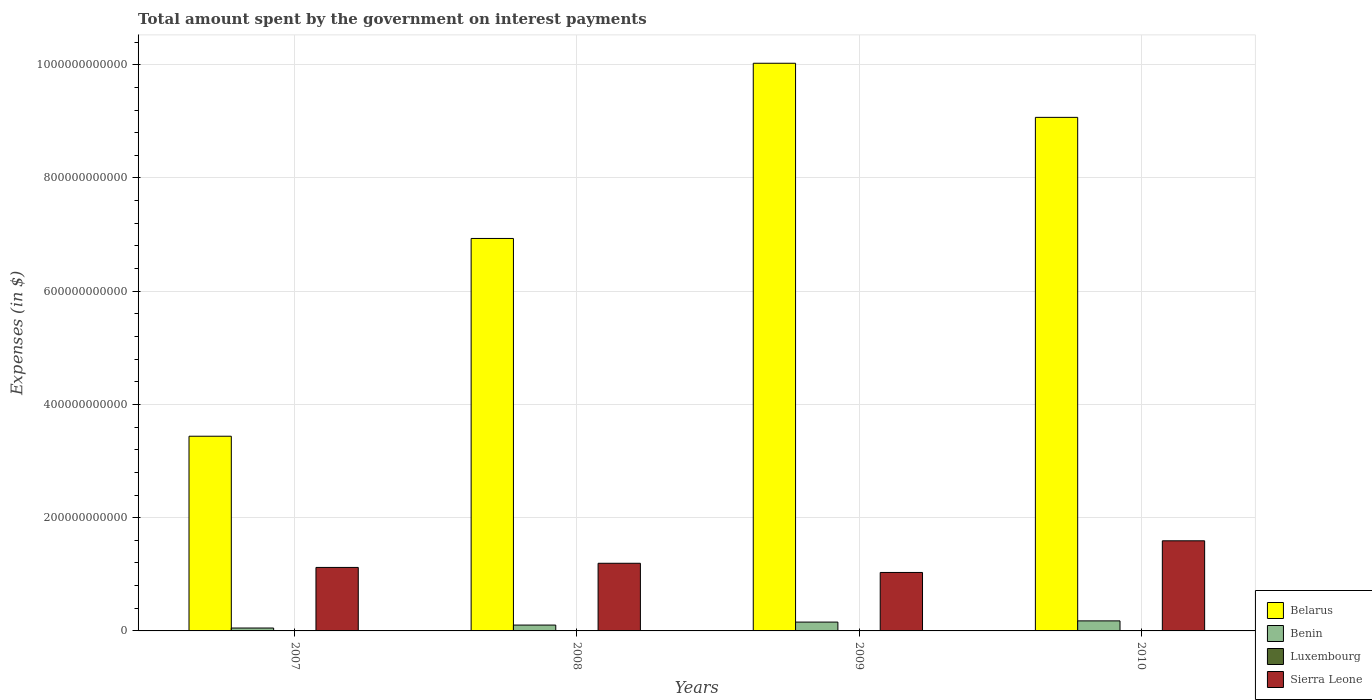How many groups of bars are there?
Your answer should be compact. 4. Are the number of bars per tick equal to the number of legend labels?
Keep it short and to the point. Yes. How many bars are there on the 2nd tick from the right?
Your answer should be very brief. 4. In how many cases, is the number of bars for a given year not equal to the number of legend labels?
Offer a terse response. 0. What is the amount spent on interest payments by the government in Sierra Leone in 2008?
Make the answer very short. 1.19e+11. Across all years, what is the maximum amount spent on interest payments by the government in Benin?
Give a very brief answer. 1.77e+1. Across all years, what is the minimum amount spent on interest payments by the government in Benin?
Keep it short and to the point. 5.13e+09. What is the total amount spent on interest payments by the government in Belarus in the graph?
Provide a short and direct response. 2.95e+12. What is the difference between the amount spent on interest payments by the government in Sierra Leone in 2008 and that in 2010?
Make the answer very short. -3.97e+1. What is the difference between the amount spent on interest payments by the government in Benin in 2008 and the amount spent on interest payments by the government in Sierra Leone in 2009?
Offer a terse response. -9.29e+1. What is the average amount spent on interest payments by the government in Benin per year?
Provide a succinct answer. 1.22e+1. In the year 2007, what is the difference between the amount spent on interest payments by the government in Benin and amount spent on interest payments by the government in Luxembourg?
Offer a very short reply. 5.07e+09. In how many years, is the amount spent on interest payments by the government in Sierra Leone greater than 40000000000 $?
Offer a very short reply. 4. What is the ratio of the amount spent on interest payments by the government in Benin in 2008 to that in 2009?
Give a very brief answer. 0.66. Is the amount spent on interest payments by the government in Benin in 2007 less than that in 2010?
Provide a short and direct response. Yes. Is the difference between the amount spent on interest payments by the government in Benin in 2007 and 2010 greater than the difference between the amount spent on interest payments by the government in Luxembourg in 2007 and 2010?
Provide a short and direct response. No. What is the difference between the highest and the second highest amount spent on interest payments by the government in Benin?
Give a very brief answer. 2.14e+09. What is the difference between the highest and the lowest amount spent on interest payments by the government in Luxembourg?
Keep it short and to the point. 9.34e+07. In how many years, is the amount spent on interest payments by the government in Luxembourg greater than the average amount spent on interest payments by the government in Luxembourg taken over all years?
Offer a terse response. 2. Is the sum of the amount spent on interest payments by the government in Luxembourg in 2008 and 2009 greater than the maximum amount spent on interest payments by the government in Benin across all years?
Your answer should be compact. No. Is it the case that in every year, the sum of the amount spent on interest payments by the government in Belarus and amount spent on interest payments by the government in Luxembourg is greater than the sum of amount spent on interest payments by the government in Sierra Leone and amount spent on interest payments by the government in Benin?
Provide a short and direct response. Yes. What does the 1st bar from the left in 2010 represents?
Your response must be concise. Belarus. What does the 2nd bar from the right in 2007 represents?
Give a very brief answer. Luxembourg. How many bars are there?
Make the answer very short. 16. What is the difference between two consecutive major ticks on the Y-axis?
Provide a succinct answer. 2.00e+11. Does the graph contain any zero values?
Ensure brevity in your answer.  No. Where does the legend appear in the graph?
Ensure brevity in your answer.  Bottom right. How are the legend labels stacked?
Offer a very short reply. Vertical. What is the title of the graph?
Give a very brief answer. Total amount spent by the government on interest payments. Does "Korea (Democratic)" appear as one of the legend labels in the graph?
Give a very brief answer. No. What is the label or title of the Y-axis?
Your response must be concise. Expenses (in $). What is the Expenses (in $) of Belarus in 2007?
Provide a short and direct response. 3.44e+11. What is the Expenses (in $) of Benin in 2007?
Make the answer very short. 5.13e+09. What is the Expenses (in $) in Luxembourg in 2007?
Your answer should be compact. 5.74e+07. What is the Expenses (in $) of Sierra Leone in 2007?
Make the answer very short. 1.12e+11. What is the Expenses (in $) in Belarus in 2008?
Your answer should be very brief. 6.93e+11. What is the Expenses (in $) of Benin in 2008?
Your answer should be compact. 1.03e+1. What is the Expenses (in $) of Luxembourg in 2008?
Offer a very short reply. 8.89e+07. What is the Expenses (in $) in Sierra Leone in 2008?
Provide a succinct answer. 1.19e+11. What is the Expenses (in $) in Belarus in 2009?
Your response must be concise. 1.00e+12. What is the Expenses (in $) in Benin in 2009?
Offer a very short reply. 1.56e+1. What is the Expenses (in $) of Luxembourg in 2009?
Give a very brief answer. 1.20e+08. What is the Expenses (in $) of Sierra Leone in 2009?
Offer a terse response. 1.03e+11. What is the Expenses (in $) in Belarus in 2010?
Make the answer very short. 9.07e+11. What is the Expenses (in $) of Benin in 2010?
Your answer should be very brief. 1.77e+1. What is the Expenses (in $) of Luxembourg in 2010?
Make the answer very short. 1.51e+08. What is the Expenses (in $) of Sierra Leone in 2010?
Make the answer very short. 1.59e+11. Across all years, what is the maximum Expenses (in $) in Belarus?
Your answer should be very brief. 1.00e+12. Across all years, what is the maximum Expenses (in $) of Benin?
Offer a very short reply. 1.77e+1. Across all years, what is the maximum Expenses (in $) of Luxembourg?
Offer a terse response. 1.51e+08. Across all years, what is the maximum Expenses (in $) of Sierra Leone?
Your answer should be very brief. 1.59e+11. Across all years, what is the minimum Expenses (in $) in Belarus?
Ensure brevity in your answer.  3.44e+11. Across all years, what is the minimum Expenses (in $) in Benin?
Your answer should be compact. 5.13e+09. Across all years, what is the minimum Expenses (in $) of Luxembourg?
Keep it short and to the point. 5.74e+07. Across all years, what is the minimum Expenses (in $) in Sierra Leone?
Your answer should be very brief. 1.03e+11. What is the total Expenses (in $) of Belarus in the graph?
Your answer should be very brief. 2.95e+12. What is the total Expenses (in $) in Benin in the graph?
Provide a succinct answer. 4.88e+1. What is the total Expenses (in $) of Luxembourg in the graph?
Give a very brief answer. 4.17e+08. What is the total Expenses (in $) of Sierra Leone in the graph?
Offer a terse response. 4.94e+11. What is the difference between the Expenses (in $) of Belarus in 2007 and that in 2008?
Provide a succinct answer. -3.49e+11. What is the difference between the Expenses (in $) of Benin in 2007 and that in 2008?
Make the answer very short. -5.22e+09. What is the difference between the Expenses (in $) in Luxembourg in 2007 and that in 2008?
Keep it short and to the point. -3.15e+07. What is the difference between the Expenses (in $) in Sierra Leone in 2007 and that in 2008?
Offer a very short reply. -7.35e+09. What is the difference between the Expenses (in $) of Belarus in 2007 and that in 2009?
Ensure brevity in your answer.  -6.59e+11. What is the difference between the Expenses (in $) in Benin in 2007 and that in 2009?
Make the answer very short. -1.05e+1. What is the difference between the Expenses (in $) of Luxembourg in 2007 and that in 2009?
Ensure brevity in your answer.  -6.29e+07. What is the difference between the Expenses (in $) of Sierra Leone in 2007 and that in 2009?
Your answer should be compact. 8.90e+09. What is the difference between the Expenses (in $) of Belarus in 2007 and that in 2010?
Give a very brief answer. -5.63e+11. What is the difference between the Expenses (in $) in Benin in 2007 and that in 2010?
Your answer should be compact. -1.26e+1. What is the difference between the Expenses (in $) of Luxembourg in 2007 and that in 2010?
Keep it short and to the point. -9.34e+07. What is the difference between the Expenses (in $) in Sierra Leone in 2007 and that in 2010?
Offer a very short reply. -4.70e+1. What is the difference between the Expenses (in $) of Belarus in 2008 and that in 2009?
Your answer should be very brief. -3.09e+11. What is the difference between the Expenses (in $) of Benin in 2008 and that in 2009?
Make the answer very short. -5.25e+09. What is the difference between the Expenses (in $) in Luxembourg in 2008 and that in 2009?
Keep it short and to the point. -3.14e+07. What is the difference between the Expenses (in $) in Sierra Leone in 2008 and that in 2009?
Your answer should be very brief. 1.62e+1. What is the difference between the Expenses (in $) in Belarus in 2008 and that in 2010?
Provide a short and direct response. -2.14e+11. What is the difference between the Expenses (in $) of Benin in 2008 and that in 2010?
Give a very brief answer. -7.39e+09. What is the difference between the Expenses (in $) in Luxembourg in 2008 and that in 2010?
Your answer should be compact. -6.20e+07. What is the difference between the Expenses (in $) in Sierra Leone in 2008 and that in 2010?
Offer a very short reply. -3.97e+1. What is the difference between the Expenses (in $) of Belarus in 2009 and that in 2010?
Your answer should be very brief. 9.56e+1. What is the difference between the Expenses (in $) of Benin in 2009 and that in 2010?
Keep it short and to the point. -2.14e+09. What is the difference between the Expenses (in $) of Luxembourg in 2009 and that in 2010?
Your answer should be compact. -3.06e+07. What is the difference between the Expenses (in $) of Sierra Leone in 2009 and that in 2010?
Offer a very short reply. -5.59e+1. What is the difference between the Expenses (in $) in Belarus in 2007 and the Expenses (in $) in Benin in 2008?
Provide a succinct answer. 3.34e+11. What is the difference between the Expenses (in $) of Belarus in 2007 and the Expenses (in $) of Luxembourg in 2008?
Ensure brevity in your answer.  3.44e+11. What is the difference between the Expenses (in $) in Belarus in 2007 and the Expenses (in $) in Sierra Leone in 2008?
Your response must be concise. 2.24e+11. What is the difference between the Expenses (in $) in Benin in 2007 and the Expenses (in $) in Luxembourg in 2008?
Give a very brief answer. 5.04e+09. What is the difference between the Expenses (in $) in Benin in 2007 and the Expenses (in $) in Sierra Leone in 2008?
Ensure brevity in your answer.  -1.14e+11. What is the difference between the Expenses (in $) in Luxembourg in 2007 and the Expenses (in $) in Sierra Leone in 2008?
Your answer should be very brief. -1.19e+11. What is the difference between the Expenses (in $) of Belarus in 2007 and the Expenses (in $) of Benin in 2009?
Provide a succinct answer. 3.28e+11. What is the difference between the Expenses (in $) of Belarus in 2007 and the Expenses (in $) of Luxembourg in 2009?
Offer a very short reply. 3.44e+11. What is the difference between the Expenses (in $) of Belarus in 2007 and the Expenses (in $) of Sierra Leone in 2009?
Provide a short and direct response. 2.41e+11. What is the difference between the Expenses (in $) of Benin in 2007 and the Expenses (in $) of Luxembourg in 2009?
Keep it short and to the point. 5.01e+09. What is the difference between the Expenses (in $) in Benin in 2007 and the Expenses (in $) in Sierra Leone in 2009?
Offer a very short reply. -9.81e+1. What is the difference between the Expenses (in $) in Luxembourg in 2007 and the Expenses (in $) in Sierra Leone in 2009?
Provide a succinct answer. -1.03e+11. What is the difference between the Expenses (in $) in Belarus in 2007 and the Expenses (in $) in Benin in 2010?
Make the answer very short. 3.26e+11. What is the difference between the Expenses (in $) in Belarus in 2007 and the Expenses (in $) in Luxembourg in 2010?
Your answer should be compact. 3.44e+11. What is the difference between the Expenses (in $) of Belarus in 2007 and the Expenses (in $) of Sierra Leone in 2010?
Make the answer very short. 1.85e+11. What is the difference between the Expenses (in $) in Benin in 2007 and the Expenses (in $) in Luxembourg in 2010?
Your response must be concise. 4.98e+09. What is the difference between the Expenses (in $) of Benin in 2007 and the Expenses (in $) of Sierra Leone in 2010?
Provide a succinct answer. -1.54e+11. What is the difference between the Expenses (in $) in Luxembourg in 2007 and the Expenses (in $) in Sierra Leone in 2010?
Ensure brevity in your answer.  -1.59e+11. What is the difference between the Expenses (in $) of Belarus in 2008 and the Expenses (in $) of Benin in 2009?
Provide a short and direct response. 6.78e+11. What is the difference between the Expenses (in $) of Belarus in 2008 and the Expenses (in $) of Luxembourg in 2009?
Provide a succinct answer. 6.93e+11. What is the difference between the Expenses (in $) of Belarus in 2008 and the Expenses (in $) of Sierra Leone in 2009?
Give a very brief answer. 5.90e+11. What is the difference between the Expenses (in $) of Benin in 2008 and the Expenses (in $) of Luxembourg in 2009?
Your response must be concise. 1.02e+1. What is the difference between the Expenses (in $) in Benin in 2008 and the Expenses (in $) in Sierra Leone in 2009?
Make the answer very short. -9.29e+1. What is the difference between the Expenses (in $) of Luxembourg in 2008 and the Expenses (in $) of Sierra Leone in 2009?
Make the answer very short. -1.03e+11. What is the difference between the Expenses (in $) of Belarus in 2008 and the Expenses (in $) of Benin in 2010?
Offer a terse response. 6.75e+11. What is the difference between the Expenses (in $) in Belarus in 2008 and the Expenses (in $) in Luxembourg in 2010?
Ensure brevity in your answer.  6.93e+11. What is the difference between the Expenses (in $) in Belarus in 2008 and the Expenses (in $) in Sierra Leone in 2010?
Ensure brevity in your answer.  5.34e+11. What is the difference between the Expenses (in $) in Benin in 2008 and the Expenses (in $) in Luxembourg in 2010?
Ensure brevity in your answer.  1.02e+1. What is the difference between the Expenses (in $) of Benin in 2008 and the Expenses (in $) of Sierra Leone in 2010?
Your answer should be very brief. -1.49e+11. What is the difference between the Expenses (in $) of Luxembourg in 2008 and the Expenses (in $) of Sierra Leone in 2010?
Give a very brief answer. -1.59e+11. What is the difference between the Expenses (in $) of Belarus in 2009 and the Expenses (in $) of Benin in 2010?
Make the answer very short. 9.85e+11. What is the difference between the Expenses (in $) in Belarus in 2009 and the Expenses (in $) in Luxembourg in 2010?
Make the answer very short. 1.00e+12. What is the difference between the Expenses (in $) in Belarus in 2009 and the Expenses (in $) in Sierra Leone in 2010?
Keep it short and to the point. 8.43e+11. What is the difference between the Expenses (in $) of Benin in 2009 and the Expenses (in $) of Luxembourg in 2010?
Make the answer very short. 1.54e+1. What is the difference between the Expenses (in $) of Benin in 2009 and the Expenses (in $) of Sierra Leone in 2010?
Provide a succinct answer. -1.44e+11. What is the difference between the Expenses (in $) of Luxembourg in 2009 and the Expenses (in $) of Sierra Leone in 2010?
Offer a very short reply. -1.59e+11. What is the average Expenses (in $) of Belarus per year?
Offer a very short reply. 7.37e+11. What is the average Expenses (in $) of Benin per year?
Provide a short and direct response. 1.22e+1. What is the average Expenses (in $) in Luxembourg per year?
Give a very brief answer. 1.04e+08. What is the average Expenses (in $) of Sierra Leone per year?
Your response must be concise. 1.24e+11. In the year 2007, what is the difference between the Expenses (in $) of Belarus and Expenses (in $) of Benin?
Provide a succinct answer. 3.39e+11. In the year 2007, what is the difference between the Expenses (in $) in Belarus and Expenses (in $) in Luxembourg?
Give a very brief answer. 3.44e+11. In the year 2007, what is the difference between the Expenses (in $) of Belarus and Expenses (in $) of Sierra Leone?
Provide a short and direct response. 2.32e+11. In the year 2007, what is the difference between the Expenses (in $) in Benin and Expenses (in $) in Luxembourg?
Give a very brief answer. 5.07e+09. In the year 2007, what is the difference between the Expenses (in $) in Benin and Expenses (in $) in Sierra Leone?
Offer a terse response. -1.07e+11. In the year 2007, what is the difference between the Expenses (in $) of Luxembourg and Expenses (in $) of Sierra Leone?
Ensure brevity in your answer.  -1.12e+11. In the year 2008, what is the difference between the Expenses (in $) in Belarus and Expenses (in $) in Benin?
Your answer should be very brief. 6.83e+11. In the year 2008, what is the difference between the Expenses (in $) of Belarus and Expenses (in $) of Luxembourg?
Give a very brief answer. 6.93e+11. In the year 2008, what is the difference between the Expenses (in $) of Belarus and Expenses (in $) of Sierra Leone?
Make the answer very short. 5.74e+11. In the year 2008, what is the difference between the Expenses (in $) in Benin and Expenses (in $) in Luxembourg?
Your answer should be compact. 1.03e+1. In the year 2008, what is the difference between the Expenses (in $) of Benin and Expenses (in $) of Sierra Leone?
Make the answer very short. -1.09e+11. In the year 2008, what is the difference between the Expenses (in $) of Luxembourg and Expenses (in $) of Sierra Leone?
Offer a terse response. -1.19e+11. In the year 2009, what is the difference between the Expenses (in $) of Belarus and Expenses (in $) of Benin?
Keep it short and to the point. 9.87e+11. In the year 2009, what is the difference between the Expenses (in $) of Belarus and Expenses (in $) of Luxembourg?
Your answer should be very brief. 1.00e+12. In the year 2009, what is the difference between the Expenses (in $) in Belarus and Expenses (in $) in Sierra Leone?
Your answer should be very brief. 8.99e+11. In the year 2009, what is the difference between the Expenses (in $) in Benin and Expenses (in $) in Luxembourg?
Your response must be concise. 1.55e+1. In the year 2009, what is the difference between the Expenses (in $) of Benin and Expenses (in $) of Sierra Leone?
Keep it short and to the point. -8.76e+1. In the year 2009, what is the difference between the Expenses (in $) of Luxembourg and Expenses (in $) of Sierra Leone?
Give a very brief answer. -1.03e+11. In the year 2010, what is the difference between the Expenses (in $) in Belarus and Expenses (in $) in Benin?
Offer a very short reply. 8.89e+11. In the year 2010, what is the difference between the Expenses (in $) of Belarus and Expenses (in $) of Luxembourg?
Provide a short and direct response. 9.07e+11. In the year 2010, what is the difference between the Expenses (in $) of Belarus and Expenses (in $) of Sierra Leone?
Provide a short and direct response. 7.48e+11. In the year 2010, what is the difference between the Expenses (in $) of Benin and Expenses (in $) of Luxembourg?
Provide a succinct answer. 1.76e+1. In the year 2010, what is the difference between the Expenses (in $) of Benin and Expenses (in $) of Sierra Leone?
Make the answer very short. -1.41e+11. In the year 2010, what is the difference between the Expenses (in $) of Luxembourg and Expenses (in $) of Sierra Leone?
Your answer should be compact. -1.59e+11. What is the ratio of the Expenses (in $) in Belarus in 2007 to that in 2008?
Provide a short and direct response. 0.5. What is the ratio of the Expenses (in $) in Benin in 2007 to that in 2008?
Your answer should be very brief. 0.5. What is the ratio of the Expenses (in $) of Luxembourg in 2007 to that in 2008?
Keep it short and to the point. 0.65. What is the ratio of the Expenses (in $) in Sierra Leone in 2007 to that in 2008?
Your answer should be very brief. 0.94. What is the ratio of the Expenses (in $) in Belarus in 2007 to that in 2009?
Give a very brief answer. 0.34. What is the ratio of the Expenses (in $) in Benin in 2007 to that in 2009?
Offer a terse response. 0.33. What is the ratio of the Expenses (in $) in Luxembourg in 2007 to that in 2009?
Ensure brevity in your answer.  0.48. What is the ratio of the Expenses (in $) of Sierra Leone in 2007 to that in 2009?
Your answer should be compact. 1.09. What is the ratio of the Expenses (in $) of Belarus in 2007 to that in 2010?
Provide a short and direct response. 0.38. What is the ratio of the Expenses (in $) of Benin in 2007 to that in 2010?
Provide a succinct answer. 0.29. What is the ratio of the Expenses (in $) of Luxembourg in 2007 to that in 2010?
Keep it short and to the point. 0.38. What is the ratio of the Expenses (in $) in Sierra Leone in 2007 to that in 2010?
Offer a terse response. 0.7. What is the ratio of the Expenses (in $) of Belarus in 2008 to that in 2009?
Provide a succinct answer. 0.69. What is the ratio of the Expenses (in $) of Benin in 2008 to that in 2009?
Make the answer very short. 0.66. What is the ratio of the Expenses (in $) in Luxembourg in 2008 to that in 2009?
Make the answer very short. 0.74. What is the ratio of the Expenses (in $) of Sierra Leone in 2008 to that in 2009?
Ensure brevity in your answer.  1.16. What is the ratio of the Expenses (in $) of Belarus in 2008 to that in 2010?
Your answer should be compact. 0.76. What is the ratio of the Expenses (in $) in Benin in 2008 to that in 2010?
Provide a short and direct response. 0.58. What is the ratio of the Expenses (in $) of Luxembourg in 2008 to that in 2010?
Provide a succinct answer. 0.59. What is the ratio of the Expenses (in $) in Sierra Leone in 2008 to that in 2010?
Offer a terse response. 0.75. What is the ratio of the Expenses (in $) in Belarus in 2009 to that in 2010?
Offer a terse response. 1.11. What is the ratio of the Expenses (in $) of Benin in 2009 to that in 2010?
Offer a terse response. 0.88. What is the ratio of the Expenses (in $) of Luxembourg in 2009 to that in 2010?
Your answer should be compact. 0.8. What is the ratio of the Expenses (in $) in Sierra Leone in 2009 to that in 2010?
Offer a very short reply. 0.65. What is the difference between the highest and the second highest Expenses (in $) in Belarus?
Provide a succinct answer. 9.56e+1. What is the difference between the highest and the second highest Expenses (in $) in Benin?
Offer a very short reply. 2.14e+09. What is the difference between the highest and the second highest Expenses (in $) in Luxembourg?
Offer a very short reply. 3.06e+07. What is the difference between the highest and the second highest Expenses (in $) of Sierra Leone?
Ensure brevity in your answer.  3.97e+1. What is the difference between the highest and the lowest Expenses (in $) of Belarus?
Your answer should be compact. 6.59e+11. What is the difference between the highest and the lowest Expenses (in $) of Benin?
Your answer should be very brief. 1.26e+1. What is the difference between the highest and the lowest Expenses (in $) of Luxembourg?
Offer a very short reply. 9.34e+07. What is the difference between the highest and the lowest Expenses (in $) in Sierra Leone?
Your response must be concise. 5.59e+1. 